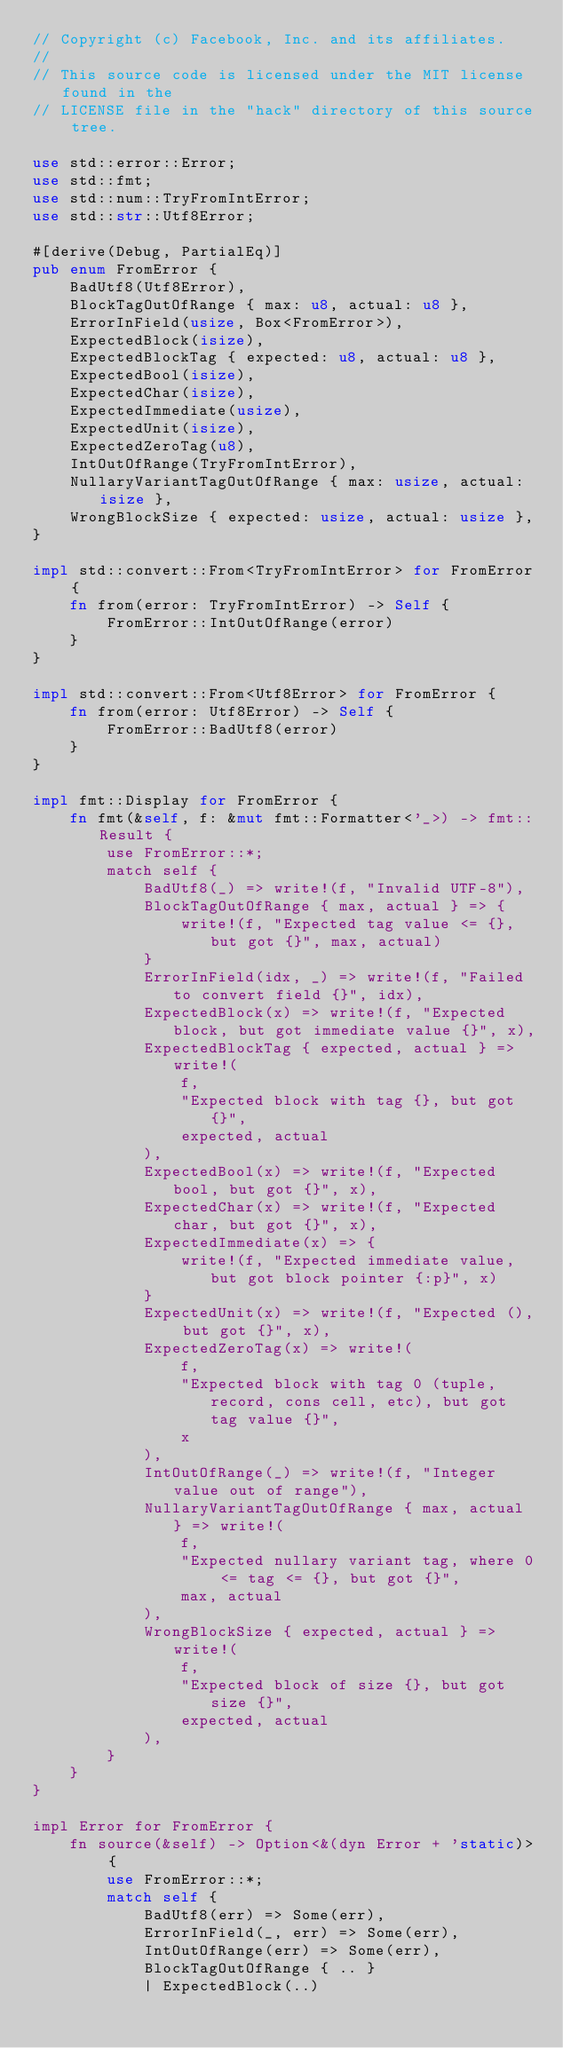<code> <loc_0><loc_0><loc_500><loc_500><_Rust_>// Copyright (c) Facebook, Inc. and its affiliates.
//
// This source code is licensed under the MIT license found in the
// LICENSE file in the "hack" directory of this source tree.

use std::error::Error;
use std::fmt;
use std::num::TryFromIntError;
use std::str::Utf8Error;

#[derive(Debug, PartialEq)]
pub enum FromError {
    BadUtf8(Utf8Error),
    BlockTagOutOfRange { max: u8, actual: u8 },
    ErrorInField(usize, Box<FromError>),
    ExpectedBlock(isize),
    ExpectedBlockTag { expected: u8, actual: u8 },
    ExpectedBool(isize),
    ExpectedChar(isize),
    ExpectedImmediate(usize),
    ExpectedUnit(isize),
    ExpectedZeroTag(u8),
    IntOutOfRange(TryFromIntError),
    NullaryVariantTagOutOfRange { max: usize, actual: isize },
    WrongBlockSize { expected: usize, actual: usize },
}

impl std::convert::From<TryFromIntError> for FromError {
    fn from(error: TryFromIntError) -> Self {
        FromError::IntOutOfRange(error)
    }
}

impl std::convert::From<Utf8Error> for FromError {
    fn from(error: Utf8Error) -> Self {
        FromError::BadUtf8(error)
    }
}

impl fmt::Display for FromError {
    fn fmt(&self, f: &mut fmt::Formatter<'_>) -> fmt::Result {
        use FromError::*;
        match self {
            BadUtf8(_) => write!(f, "Invalid UTF-8"),
            BlockTagOutOfRange { max, actual } => {
                write!(f, "Expected tag value <= {}, but got {}", max, actual)
            }
            ErrorInField(idx, _) => write!(f, "Failed to convert field {}", idx),
            ExpectedBlock(x) => write!(f, "Expected block, but got immediate value {}", x),
            ExpectedBlockTag { expected, actual } => write!(
                f,
                "Expected block with tag {}, but got {}",
                expected, actual
            ),
            ExpectedBool(x) => write!(f, "Expected bool, but got {}", x),
            ExpectedChar(x) => write!(f, "Expected char, but got {}", x),
            ExpectedImmediate(x) => {
                write!(f, "Expected immediate value, but got block pointer {:p}", x)
            }
            ExpectedUnit(x) => write!(f, "Expected (), but got {}", x),
            ExpectedZeroTag(x) => write!(
                f,
                "Expected block with tag 0 (tuple, record, cons cell, etc), but got tag value {}",
                x
            ),
            IntOutOfRange(_) => write!(f, "Integer value out of range"),
            NullaryVariantTagOutOfRange { max, actual } => write!(
                f,
                "Expected nullary variant tag, where 0 <= tag <= {}, but got {}",
                max, actual
            ),
            WrongBlockSize { expected, actual } => write!(
                f,
                "Expected block of size {}, but got size {}",
                expected, actual
            ),
        }
    }
}

impl Error for FromError {
    fn source(&self) -> Option<&(dyn Error + 'static)> {
        use FromError::*;
        match self {
            BadUtf8(err) => Some(err),
            ErrorInField(_, err) => Some(err),
            IntOutOfRange(err) => Some(err),
            BlockTagOutOfRange { .. }
            | ExpectedBlock(..)</code> 